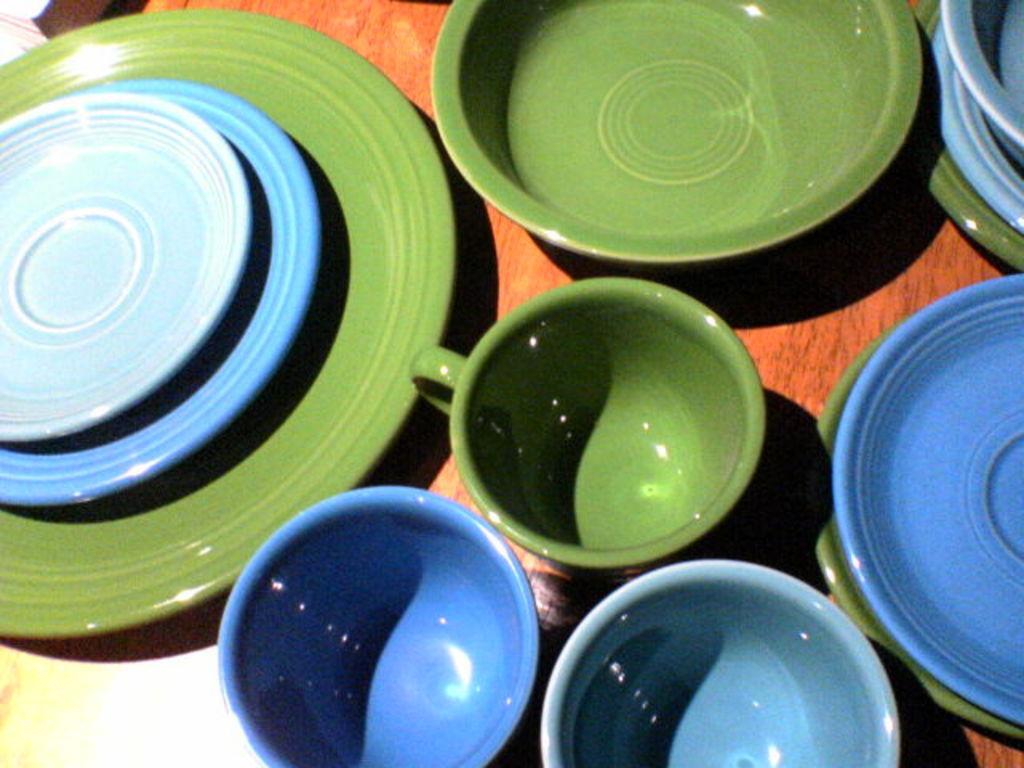Please provide a concise description of this image. We can see cups,plates and bowls on the wooden surface. 